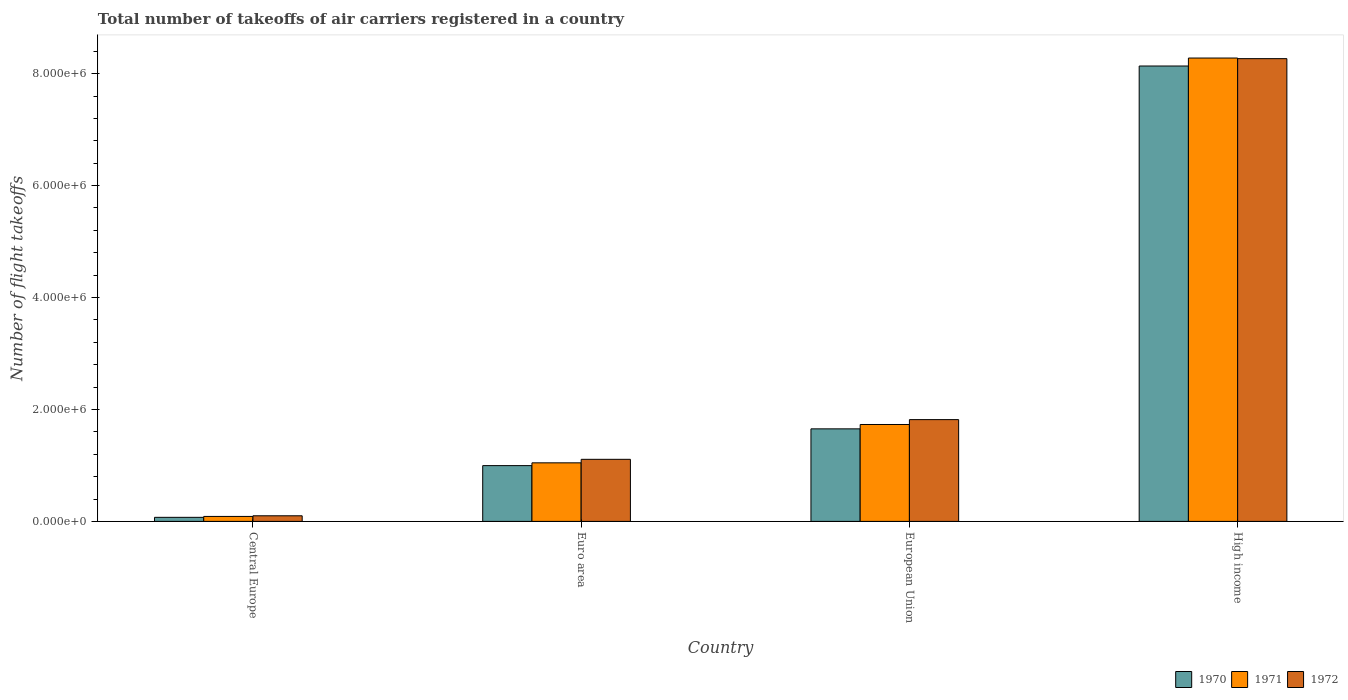How many different coloured bars are there?
Ensure brevity in your answer.  3. How many bars are there on the 2nd tick from the left?
Ensure brevity in your answer.  3. How many bars are there on the 2nd tick from the right?
Provide a succinct answer. 3. In how many cases, is the number of bars for a given country not equal to the number of legend labels?
Your response must be concise. 0. What is the total number of flight takeoffs in 1972 in European Union?
Your response must be concise. 1.82e+06. Across all countries, what is the maximum total number of flight takeoffs in 1972?
Your answer should be very brief. 8.27e+06. Across all countries, what is the minimum total number of flight takeoffs in 1971?
Your response must be concise. 8.89e+04. In which country was the total number of flight takeoffs in 1971 maximum?
Give a very brief answer. High income. In which country was the total number of flight takeoffs in 1971 minimum?
Offer a very short reply. Central Europe. What is the total total number of flight takeoffs in 1971 in the graph?
Your answer should be compact. 1.11e+07. What is the difference between the total number of flight takeoffs in 1972 in Euro area and that in European Union?
Your answer should be compact. -7.10e+05. What is the difference between the total number of flight takeoffs in 1972 in Central Europe and the total number of flight takeoffs in 1971 in High income?
Offer a terse response. -8.18e+06. What is the average total number of flight takeoffs in 1972 per country?
Provide a short and direct response. 2.82e+06. What is the difference between the total number of flight takeoffs of/in 1971 and total number of flight takeoffs of/in 1970 in Central Europe?
Provide a succinct answer. 1.62e+04. What is the ratio of the total number of flight takeoffs in 1970 in Central Europe to that in High income?
Make the answer very short. 0.01. Is the difference between the total number of flight takeoffs in 1971 in European Union and High income greater than the difference between the total number of flight takeoffs in 1970 in European Union and High income?
Provide a short and direct response. No. What is the difference between the highest and the second highest total number of flight takeoffs in 1971?
Provide a succinct answer. 6.55e+06. What is the difference between the highest and the lowest total number of flight takeoffs in 1972?
Your answer should be very brief. 8.17e+06. What does the 2nd bar from the left in Euro area represents?
Your answer should be compact. 1971. What does the 3rd bar from the right in High income represents?
Ensure brevity in your answer.  1970. How many bars are there?
Ensure brevity in your answer.  12. What is the difference between two consecutive major ticks on the Y-axis?
Provide a succinct answer. 2.00e+06. Does the graph contain any zero values?
Offer a very short reply. No. What is the title of the graph?
Ensure brevity in your answer.  Total number of takeoffs of air carriers registered in a country. Does "2000" appear as one of the legend labels in the graph?
Give a very brief answer. No. What is the label or title of the X-axis?
Your answer should be compact. Country. What is the label or title of the Y-axis?
Make the answer very short. Number of flight takeoffs. What is the Number of flight takeoffs of 1970 in Central Europe?
Make the answer very short. 7.27e+04. What is the Number of flight takeoffs of 1971 in Central Europe?
Your response must be concise. 8.89e+04. What is the Number of flight takeoffs in 1972 in Central Europe?
Your answer should be very brief. 1.00e+05. What is the Number of flight takeoffs in 1970 in Euro area?
Ensure brevity in your answer.  9.96e+05. What is the Number of flight takeoffs in 1971 in Euro area?
Your response must be concise. 1.05e+06. What is the Number of flight takeoffs in 1972 in Euro area?
Keep it short and to the point. 1.11e+06. What is the Number of flight takeoffs of 1970 in European Union?
Keep it short and to the point. 1.65e+06. What is the Number of flight takeoffs in 1971 in European Union?
Ensure brevity in your answer.  1.73e+06. What is the Number of flight takeoffs in 1972 in European Union?
Provide a succinct answer. 1.82e+06. What is the Number of flight takeoffs in 1970 in High income?
Offer a very short reply. 8.14e+06. What is the Number of flight takeoffs in 1971 in High income?
Your answer should be compact. 8.28e+06. What is the Number of flight takeoffs in 1972 in High income?
Your response must be concise. 8.27e+06. Across all countries, what is the maximum Number of flight takeoffs of 1970?
Your response must be concise. 8.14e+06. Across all countries, what is the maximum Number of flight takeoffs of 1971?
Make the answer very short. 8.28e+06. Across all countries, what is the maximum Number of flight takeoffs in 1972?
Your answer should be very brief. 8.27e+06. Across all countries, what is the minimum Number of flight takeoffs of 1970?
Make the answer very short. 7.27e+04. Across all countries, what is the minimum Number of flight takeoffs in 1971?
Keep it short and to the point. 8.89e+04. Across all countries, what is the minimum Number of flight takeoffs of 1972?
Offer a very short reply. 1.00e+05. What is the total Number of flight takeoffs of 1970 in the graph?
Provide a succinct answer. 1.09e+07. What is the total Number of flight takeoffs of 1971 in the graph?
Ensure brevity in your answer.  1.11e+07. What is the total Number of flight takeoffs in 1972 in the graph?
Your response must be concise. 1.13e+07. What is the difference between the Number of flight takeoffs of 1970 in Central Europe and that in Euro area?
Your answer should be compact. -9.24e+05. What is the difference between the Number of flight takeoffs in 1971 in Central Europe and that in Euro area?
Provide a short and direct response. -9.58e+05. What is the difference between the Number of flight takeoffs of 1972 in Central Europe and that in Euro area?
Ensure brevity in your answer.  -1.01e+06. What is the difference between the Number of flight takeoffs in 1970 in Central Europe and that in European Union?
Your answer should be compact. -1.58e+06. What is the difference between the Number of flight takeoffs in 1971 in Central Europe and that in European Union?
Offer a terse response. -1.64e+06. What is the difference between the Number of flight takeoffs of 1972 in Central Europe and that in European Union?
Ensure brevity in your answer.  -1.72e+06. What is the difference between the Number of flight takeoffs of 1970 in Central Europe and that in High income?
Your response must be concise. -8.06e+06. What is the difference between the Number of flight takeoffs in 1971 in Central Europe and that in High income?
Provide a succinct answer. -8.19e+06. What is the difference between the Number of flight takeoffs of 1972 in Central Europe and that in High income?
Give a very brief answer. -8.17e+06. What is the difference between the Number of flight takeoffs in 1970 in Euro area and that in European Union?
Provide a succinct answer. -6.57e+05. What is the difference between the Number of flight takeoffs in 1971 in Euro area and that in European Union?
Make the answer very short. -6.85e+05. What is the difference between the Number of flight takeoffs in 1972 in Euro area and that in European Union?
Keep it short and to the point. -7.10e+05. What is the difference between the Number of flight takeoffs in 1970 in Euro area and that in High income?
Provide a short and direct response. -7.14e+06. What is the difference between the Number of flight takeoffs of 1971 in Euro area and that in High income?
Make the answer very short. -7.23e+06. What is the difference between the Number of flight takeoffs of 1972 in Euro area and that in High income?
Your answer should be compact. -7.16e+06. What is the difference between the Number of flight takeoffs of 1970 in European Union and that in High income?
Your answer should be very brief. -6.48e+06. What is the difference between the Number of flight takeoffs of 1971 in European Union and that in High income?
Your answer should be compact. -6.55e+06. What is the difference between the Number of flight takeoffs of 1972 in European Union and that in High income?
Make the answer very short. -6.45e+06. What is the difference between the Number of flight takeoffs of 1970 in Central Europe and the Number of flight takeoffs of 1971 in Euro area?
Make the answer very short. -9.74e+05. What is the difference between the Number of flight takeoffs in 1970 in Central Europe and the Number of flight takeoffs in 1972 in Euro area?
Give a very brief answer. -1.04e+06. What is the difference between the Number of flight takeoffs in 1971 in Central Europe and the Number of flight takeoffs in 1972 in Euro area?
Give a very brief answer. -1.02e+06. What is the difference between the Number of flight takeoffs in 1970 in Central Europe and the Number of flight takeoffs in 1971 in European Union?
Ensure brevity in your answer.  -1.66e+06. What is the difference between the Number of flight takeoffs in 1970 in Central Europe and the Number of flight takeoffs in 1972 in European Union?
Offer a very short reply. -1.75e+06. What is the difference between the Number of flight takeoffs of 1971 in Central Europe and the Number of flight takeoffs of 1972 in European Union?
Ensure brevity in your answer.  -1.73e+06. What is the difference between the Number of flight takeoffs in 1970 in Central Europe and the Number of flight takeoffs in 1971 in High income?
Your response must be concise. -8.21e+06. What is the difference between the Number of flight takeoffs in 1970 in Central Europe and the Number of flight takeoffs in 1972 in High income?
Offer a very short reply. -8.20e+06. What is the difference between the Number of flight takeoffs of 1971 in Central Europe and the Number of flight takeoffs of 1972 in High income?
Your answer should be compact. -8.18e+06. What is the difference between the Number of flight takeoffs of 1970 in Euro area and the Number of flight takeoffs of 1971 in European Union?
Offer a terse response. -7.35e+05. What is the difference between the Number of flight takeoffs of 1970 in Euro area and the Number of flight takeoffs of 1972 in European Union?
Give a very brief answer. -8.22e+05. What is the difference between the Number of flight takeoffs of 1971 in Euro area and the Number of flight takeoffs of 1972 in European Union?
Your answer should be very brief. -7.72e+05. What is the difference between the Number of flight takeoffs of 1970 in Euro area and the Number of flight takeoffs of 1971 in High income?
Keep it short and to the point. -7.28e+06. What is the difference between the Number of flight takeoffs of 1970 in Euro area and the Number of flight takeoffs of 1972 in High income?
Ensure brevity in your answer.  -7.27e+06. What is the difference between the Number of flight takeoffs in 1971 in Euro area and the Number of flight takeoffs in 1972 in High income?
Offer a very short reply. -7.22e+06. What is the difference between the Number of flight takeoffs of 1970 in European Union and the Number of flight takeoffs of 1971 in High income?
Your response must be concise. -6.62e+06. What is the difference between the Number of flight takeoffs in 1970 in European Union and the Number of flight takeoffs in 1972 in High income?
Keep it short and to the point. -6.61e+06. What is the difference between the Number of flight takeoffs of 1971 in European Union and the Number of flight takeoffs of 1972 in High income?
Your response must be concise. -6.54e+06. What is the average Number of flight takeoffs of 1970 per country?
Offer a terse response. 2.71e+06. What is the average Number of flight takeoffs of 1971 per country?
Your answer should be very brief. 2.79e+06. What is the average Number of flight takeoffs in 1972 per country?
Provide a succinct answer. 2.82e+06. What is the difference between the Number of flight takeoffs of 1970 and Number of flight takeoffs of 1971 in Central Europe?
Give a very brief answer. -1.62e+04. What is the difference between the Number of flight takeoffs of 1970 and Number of flight takeoffs of 1972 in Central Europe?
Offer a very short reply. -2.76e+04. What is the difference between the Number of flight takeoffs in 1971 and Number of flight takeoffs in 1972 in Central Europe?
Keep it short and to the point. -1.14e+04. What is the difference between the Number of flight takeoffs in 1970 and Number of flight takeoffs in 1971 in Euro area?
Give a very brief answer. -4.99e+04. What is the difference between the Number of flight takeoffs in 1970 and Number of flight takeoffs in 1972 in Euro area?
Make the answer very short. -1.12e+05. What is the difference between the Number of flight takeoffs in 1971 and Number of flight takeoffs in 1972 in Euro area?
Provide a short and direct response. -6.26e+04. What is the difference between the Number of flight takeoffs in 1970 and Number of flight takeoffs in 1971 in European Union?
Provide a succinct answer. -7.77e+04. What is the difference between the Number of flight takeoffs of 1970 and Number of flight takeoffs of 1972 in European Union?
Offer a terse response. -1.65e+05. What is the difference between the Number of flight takeoffs of 1971 and Number of flight takeoffs of 1972 in European Union?
Your answer should be compact. -8.72e+04. What is the difference between the Number of flight takeoffs of 1970 and Number of flight takeoffs of 1971 in High income?
Provide a short and direct response. -1.42e+05. What is the difference between the Number of flight takeoffs in 1970 and Number of flight takeoffs in 1972 in High income?
Your answer should be very brief. -1.32e+05. What is the difference between the Number of flight takeoffs in 1971 and Number of flight takeoffs in 1972 in High income?
Make the answer very short. 1.09e+04. What is the ratio of the Number of flight takeoffs of 1970 in Central Europe to that in Euro area?
Provide a short and direct response. 0.07. What is the ratio of the Number of flight takeoffs of 1971 in Central Europe to that in Euro area?
Provide a short and direct response. 0.09. What is the ratio of the Number of flight takeoffs in 1972 in Central Europe to that in Euro area?
Offer a terse response. 0.09. What is the ratio of the Number of flight takeoffs of 1970 in Central Europe to that in European Union?
Your answer should be very brief. 0.04. What is the ratio of the Number of flight takeoffs in 1971 in Central Europe to that in European Union?
Keep it short and to the point. 0.05. What is the ratio of the Number of flight takeoffs in 1972 in Central Europe to that in European Union?
Make the answer very short. 0.06. What is the ratio of the Number of flight takeoffs in 1970 in Central Europe to that in High income?
Ensure brevity in your answer.  0.01. What is the ratio of the Number of flight takeoffs of 1971 in Central Europe to that in High income?
Provide a succinct answer. 0.01. What is the ratio of the Number of flight takeoffs of 1972 in Central Europe to that in High income?
Your answer should be very brief. 0.01. What is the ratio of the Number of flight takeoffs in 1970 in Euro area to that in European Union?
Offer a terse response. 0.6. What is the ratio of the Number of flight takeoffs in 1971 in Euro area to that in European Union?
Offer a terse response. 0.6. What is the ratio of the Number of flight takeoffs in 1972 in Euro area to that in European Union?
Your response must be concise. 0.61. What is the ratio of the Number of flight takeoffs in 1970 in Euro area to that in High income?
Your answer should be compact. 0.12. What is the ratio of the Number of flight takeoffs of 1971 in Euro area to that in High income?
Your answer should be very brief. 0.13. What is the ratio of the Number of flight takeoffs of 1972 in Euro area to that in High income?
Make the answer very short. 0.13. What is the ratio of the Number of flight takeoffs of 1970 in European Union to that in High income?
Your answer should be very brief. 0.2. What is the ratio of the Number of flight takeoffs in 1971 in European Union to that in High income?
Give a very brief answer. 0.21. What is the ratio of the Number of flight takeoffs of 1972 in European Union to that in High income?
Your response must be concise. 0.22. What is the difference between the highest and the second highest Number of flight takeoffs of 1970?
Your response must be concise. 6.48e+06. What is the difference between the highest and the second highest Number of flight takeoffs in 1971?
Provide a short and direct response. 6.55e+06. What is the difference between the highest and the second highest Number of flight takeoffs of 1972?
Make the answer very short. 6.45e+06. What is the difference between the highest and the lowest Number of flight takeoffs of 1970?
Give a very brief answer. 8.06e+06. What is the difference between the highest and the lowest Number of flight takeoffs in 1971?
Ensure brevity in your answer.  8.19e+06. What is the difference between the highest and the lowest Number of flight takeoffs of 1972?
Your answer should be very brief. 8.17e+06. 